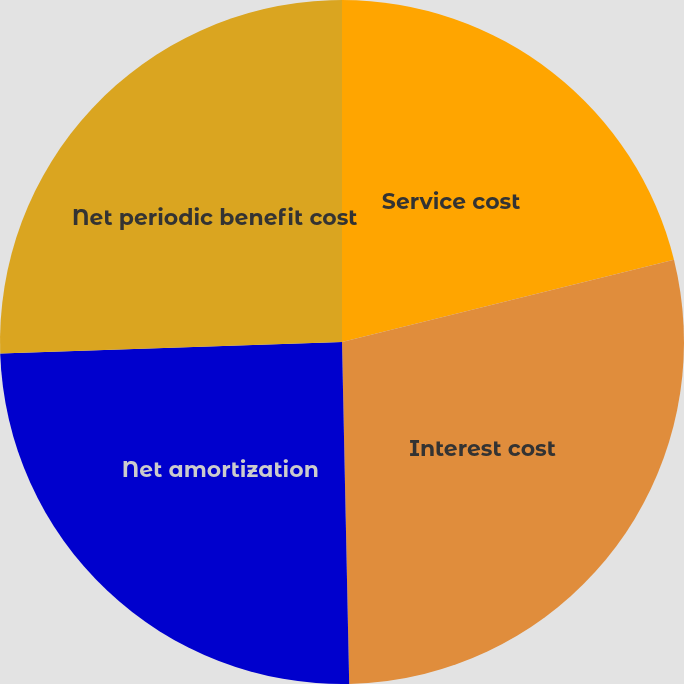<chart> <loc_0><loc_0><loc_500><loc_500><pie_chart><fcel>Service cost<fcel>Interest cost<fcel>Net amortization<fcel>Net periodic benefit cost<nl><fcel>21.14%<fcel>28.53%<fcel>24.8%<fcel>25.54%<nl></chart> 